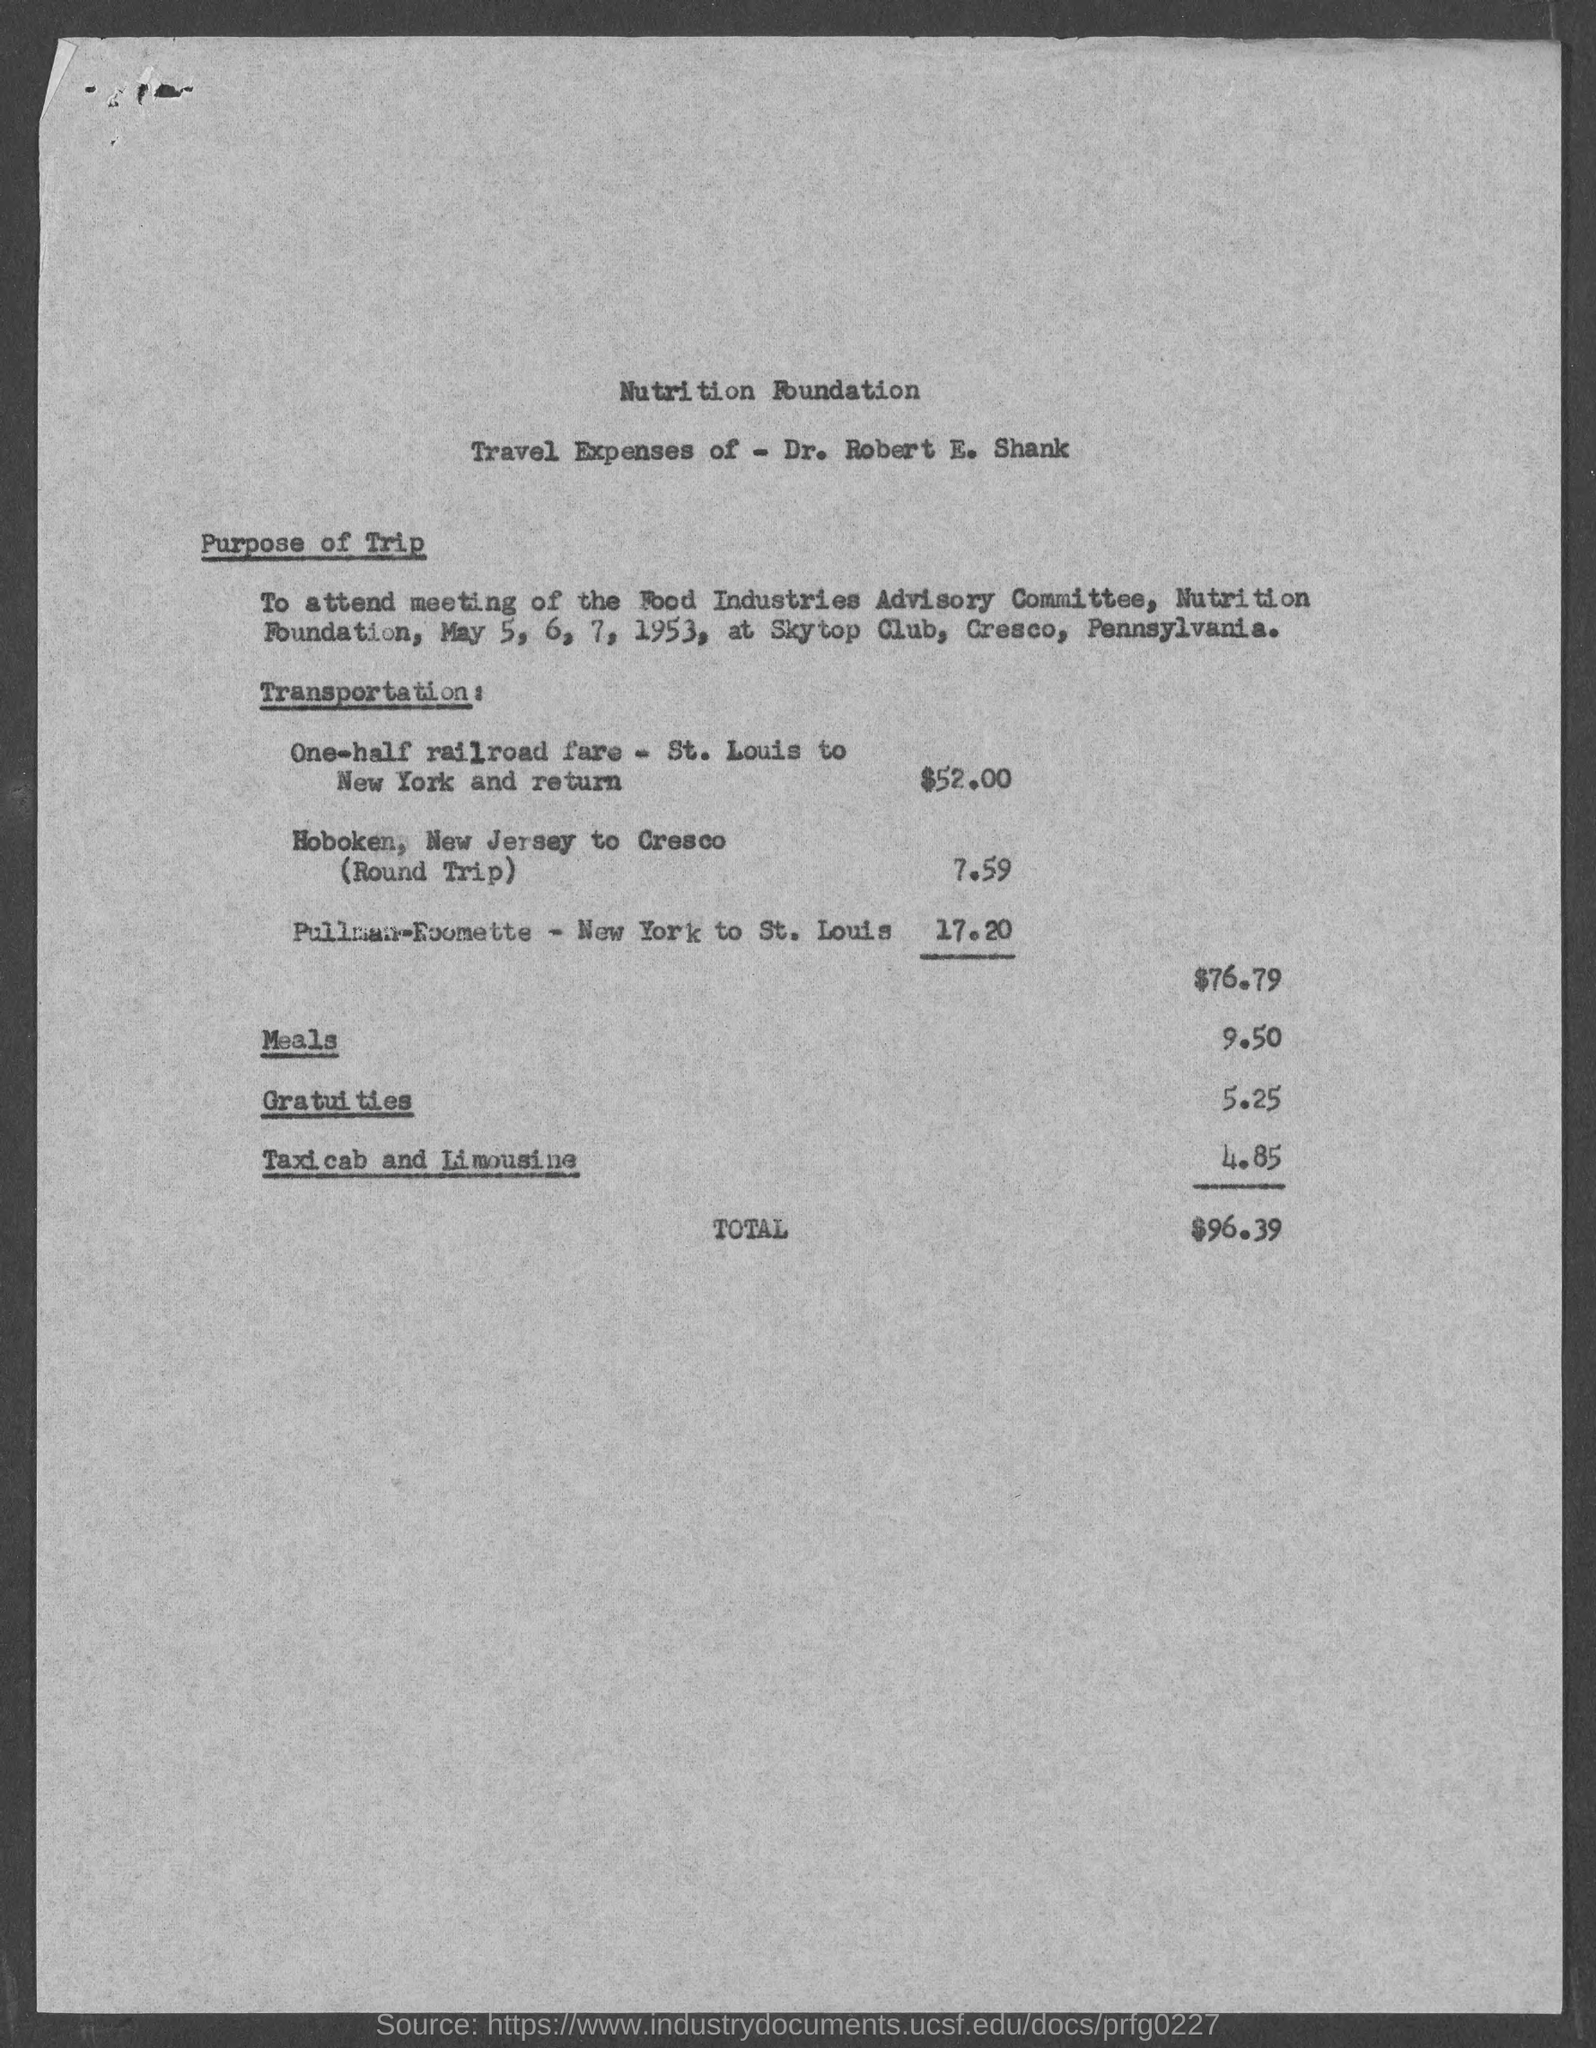Outline some significant characteristics in this image. The charge for meals is $9.50. The total amount spent on taxicabs and limousines is 4.85. The heading at the top of the page reads "Nutrition Foundation". The amount spent on gratuities is 5.25. Dr. Robert E. Shank spent a total of $96.39. 